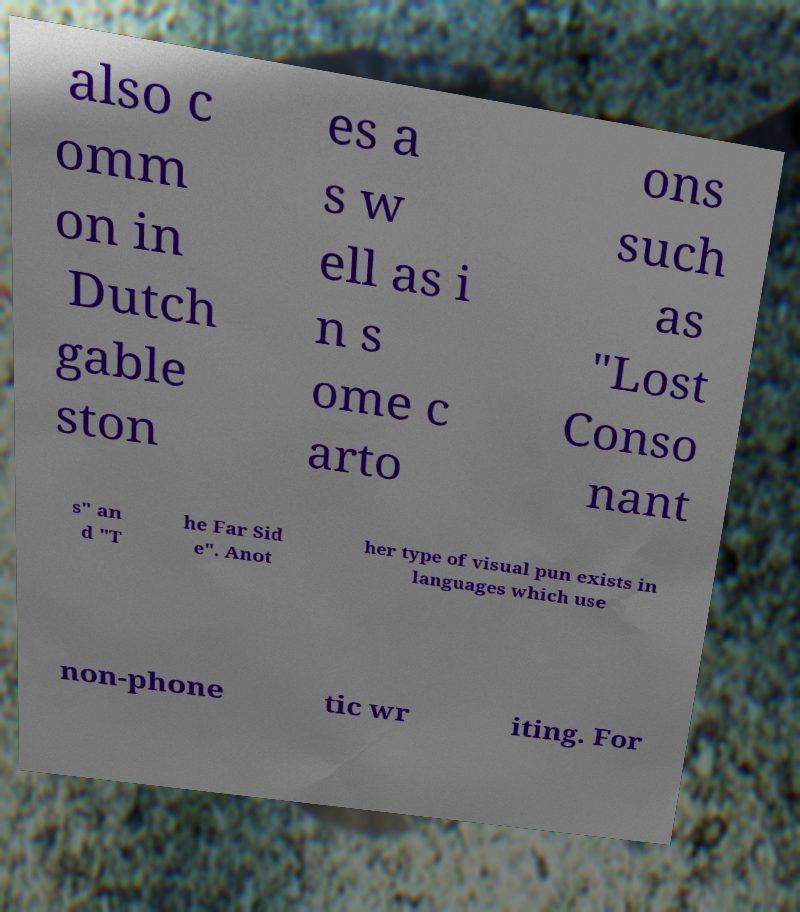Could you extract and type out the text from this image? also c omm on in Dutch gable ston es a s w ell as i n s ome c arto ons such as "Lost Conso nant s" an d "T he Far Sid e". Anot her type of visual pun exists in languages which use non-phone tic wr iting. For 